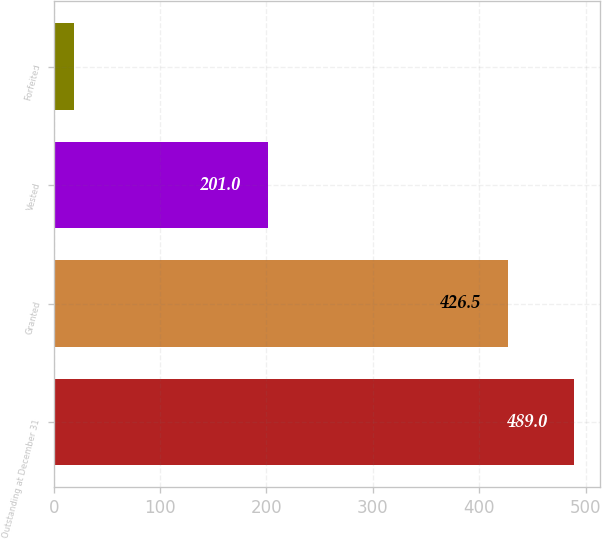<chart> <loc_0><loc_0><loc_500><loc_500><bar_chart><fcel>Outstanding at December 31<fcel>Granted<fcel>Vested<fcel>Forfeited<nl><fcel>489<fcel>426.5<fcel>201<fcel>19<nl></chart> 